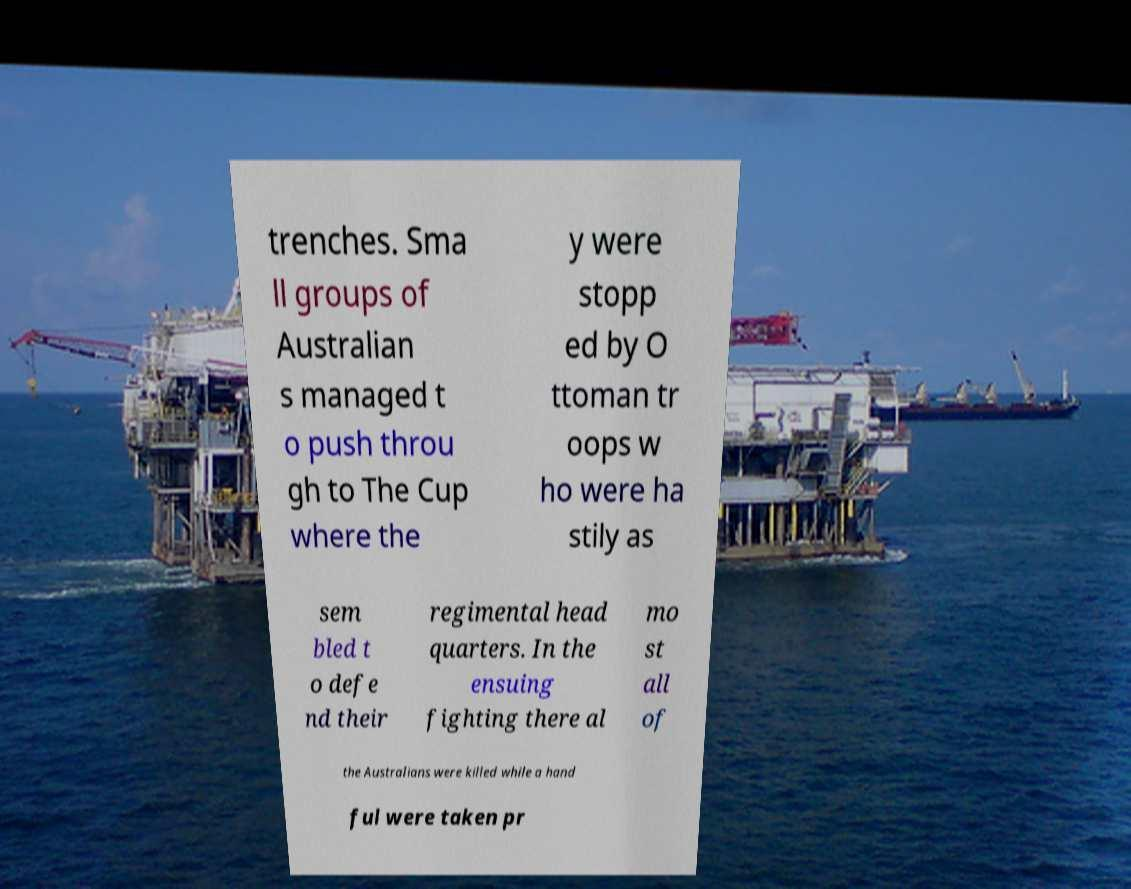Can you accurately transcribe the text from the provided image for me? trenches. Sma ll groups of Australian s managed t o push throu gh to The Cup where the y were stopp ed by O ttoman tr oops w ho were ha stily as sem bled t o defe nd their regimental head quarters. In the ensuing fighting there al mo st all of the Australians were killed while a hand ful were taken pr 